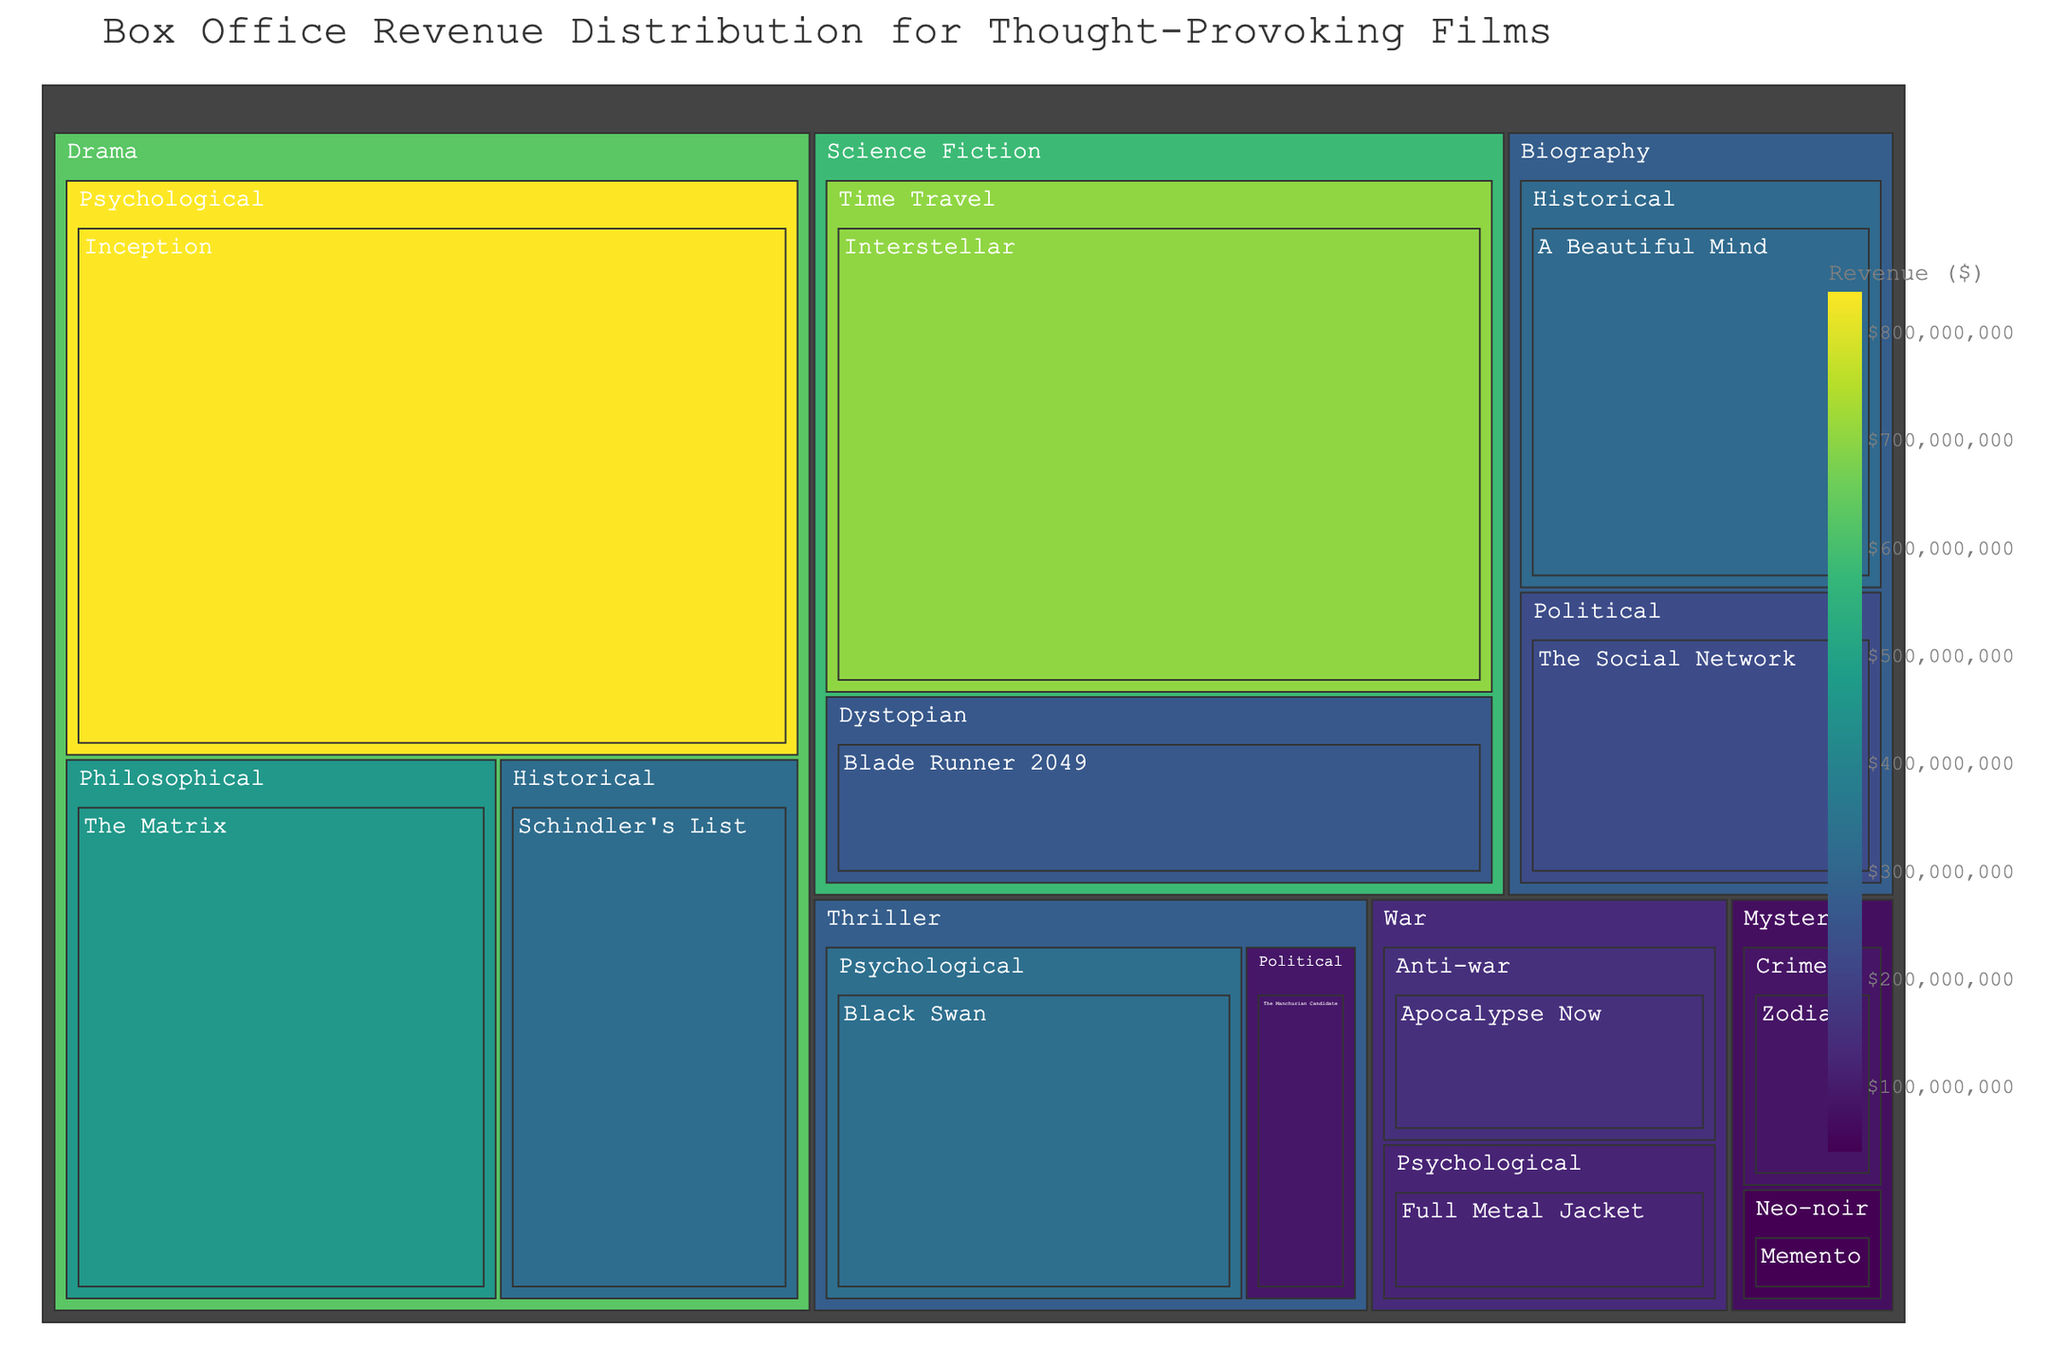What is the title of the Treemap? The title is positioned at the top of the Treemap and usually provides a clear and concise description of the visualized data.
Answer: Box Office Revenue Distribution for Thought-Provoking Films Which genre has the highest revenue? By looking at the Treemap, the area covered by each genre is proportional to its total revenue. The genre with the largest area has the highest revenue.
Answer: Drama What is the total revenue of the Science Fiction genre? To get the total revenue for the Science Fiction genre, sum up the values of its subgenres (Dystopian and Time Travel).
Answer: $961,100,000 Which film has the lowest revenue, and what is its amount? The smallest rectangle in the Treemap represents the film with the lowest revenue. Hovering over it will display its revenue.
Answer: Memento, $39,700,000 Compare the revenues of 'Inception' and 'Interstellar.' Which one has a higher revenue, and by how much? First, locate both films in the Treemap. Check their respective revenues and calculate the difference. 'Inception' has $836,800,000 and 'Interstellar' has $701,800,000. Subtract the smaller value from the larger one.
Answer: Inception, by $135,000,000 What is the revenue difference between the genres of War and Biography? Identify the total revenue for both genres: War has $270,200,000 and Biography has $538,400,000. Subtract the total revenue of War from Biography.
Answer: $268,200,000 Which subgenre within the Drama genre has the highest revenue, and what is its amount? Within the Drama genre section of the Treemap, the subgenre with the largest rectangle represents the highest revenue. Verify by hovering over the subgenre.
Answer: Psychological, $836,800,000 How many unique genres are represented in the Treemap? Each distinct top-level section in the Treemap represents a unique genre. Count these sections.
Answer: 5 If the genres of Thriller and Mystery are combined, what would their total revenue be? Add the total revenues from the Thriller and Mystery genres: Thriller has $418,500,000 and Mystery has $124,500,000. Sum these two amounts.
Answer: $543,000,000 